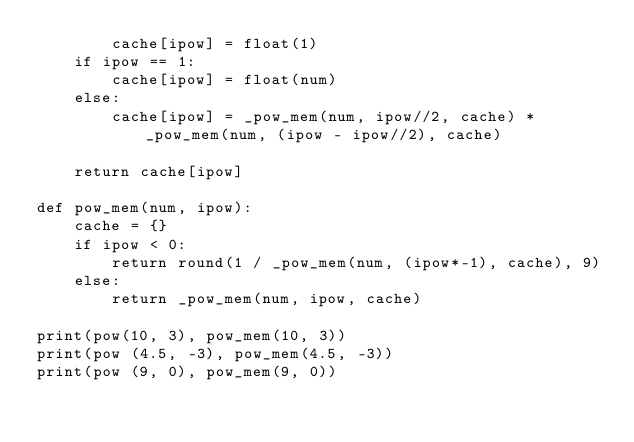<code> <loc_0><loc_0><loc_500><loc_500><_Python_>        cache[ipow] = float(1)
    if ipow == 1:
        cache[ipow] = float(num)
    else:
        cache[ipow] = _pow_mem(num, ipow//2, cache) * _pow_mem(num, (ipow - ipow//2), cache)

    return cache[ipow]

def pow_mem(num, ipow):
    cache = {}
    if ipow < 0:
        return round(1 / _pow_mem(num, (ipow*-1), cache), 9)
    else:
        return _pow_mem(num, ipow, cache)

print(pow(10, 3), pow_mem(10, 3))
print(pow (4.5, -3), pow_mem(4.5, -3))
print(pow (9, 0), pow_mem(9, 0))</code> 